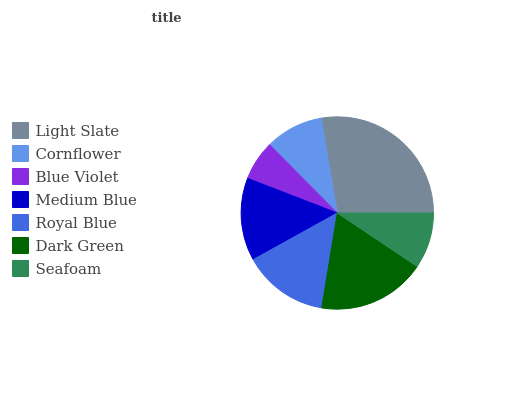Is Blue Violet the minimum?
Answer yes or no. Yes. Is Light Slate the maximum?
Answer yes or no. Yes. Is Cornflower the minimum?
Answer yes or no. No. Is Cornflower the maximum?
Answer yes or no. No. Is Light Slate greater than Cornflower?
Answer yes or no. Yes. Is Cornflower less than Light Slate?
Answer yes or no. Yes. Is Cornflower greater than Light Slate?
Answer yes or no. No. Is Light Slate less than Cornflower?
Answer yes or no. No. Is Medium Blue the high median?
Answer yes or no. Yes. Is Medium Blue the low median?
Answer yes or no. Yes. Is Light Slate the high median?
Answer yes or no. No. Is Light Slate the low median?
Answer yes or no. No. 